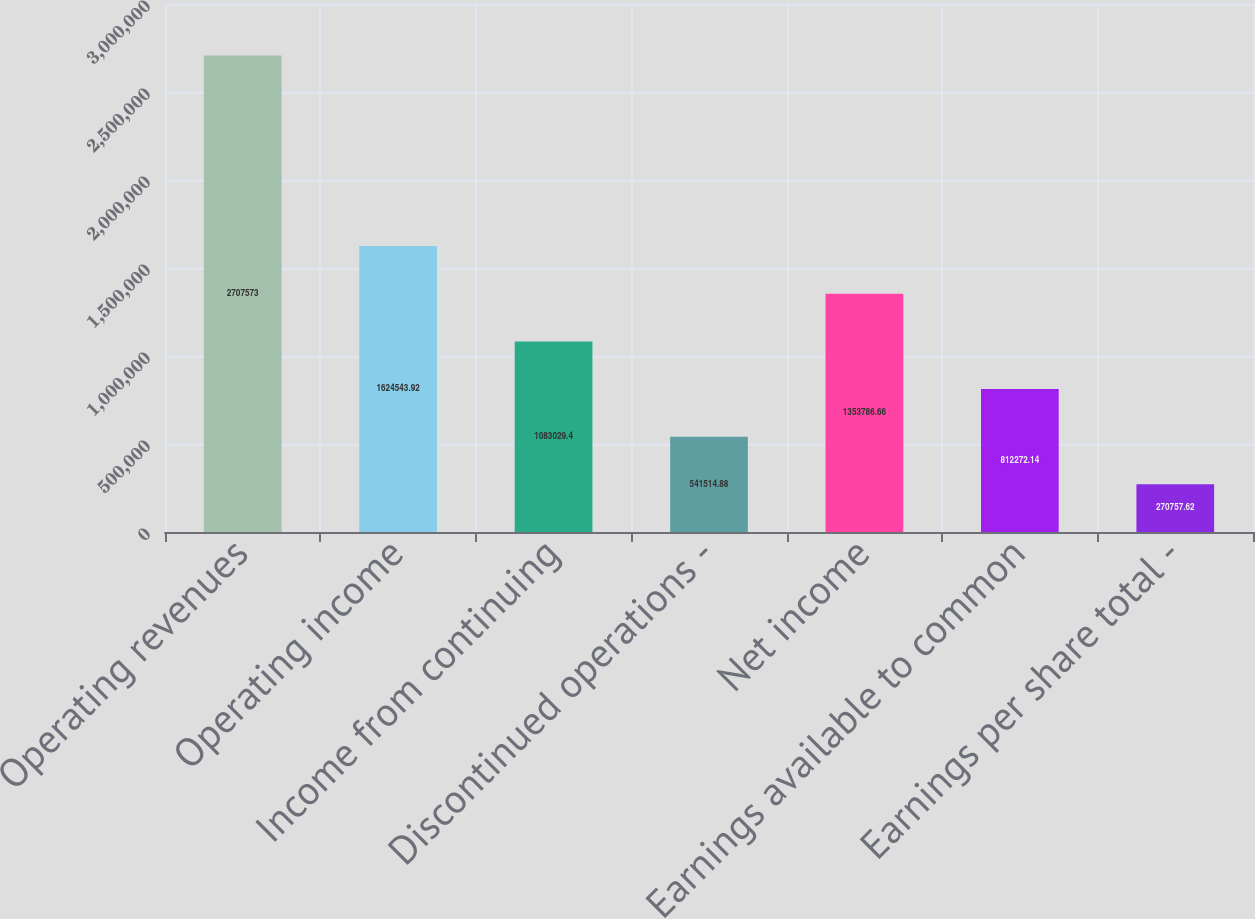<chart> <loc_0><loc_0><loc_500><loc_500><bar_chart><fcel>Operating revenues<fcel>Operating income<fcel>Income from continuing<fcel>Discontinued operations -<fcel>Net income<fcel>Earnings available to common<fcel>Earnings per share total -<nl><fcel>2.70757e+06<fcel>1.62454e+06<fcel>1.08303e+06<fcel>541515<fcel>1.35379e+06<fcel>812272<fcel>270758<nl></chart> 